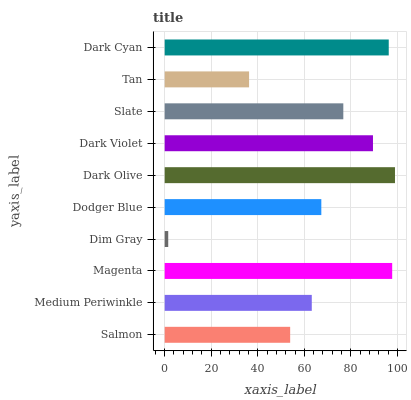Is Dim Gray the minimum?
Answer yes or no. Yes. Is Dark Olive the maximum?
Answer yes or no. Yes. Is Medium Periwinkle the minimum?
Answer yes or no. No. Is Medium Periwinkle the maximum?
Answer yes or no. No. Is Medium Periwinkle greater than Salmon?
Answer yes or no. Yes. Is Salmon less than Medium Periwinkle?
Answer yes or no. Yes. Is Salmon greater than Medium Periwinkle?
Answer yes or no. No. Is Medium Periwinkle less than Salmon?
Answer yes or no. No. Is Slate the high median?
Answer yes or no. Yes. Is Dodger Blue the low median?
Answer yes or no. Yes. Is Dark Cyan the high median?
Answer yes or no. No. Is Dark Olive the low median?
Answer yes or no. No. 